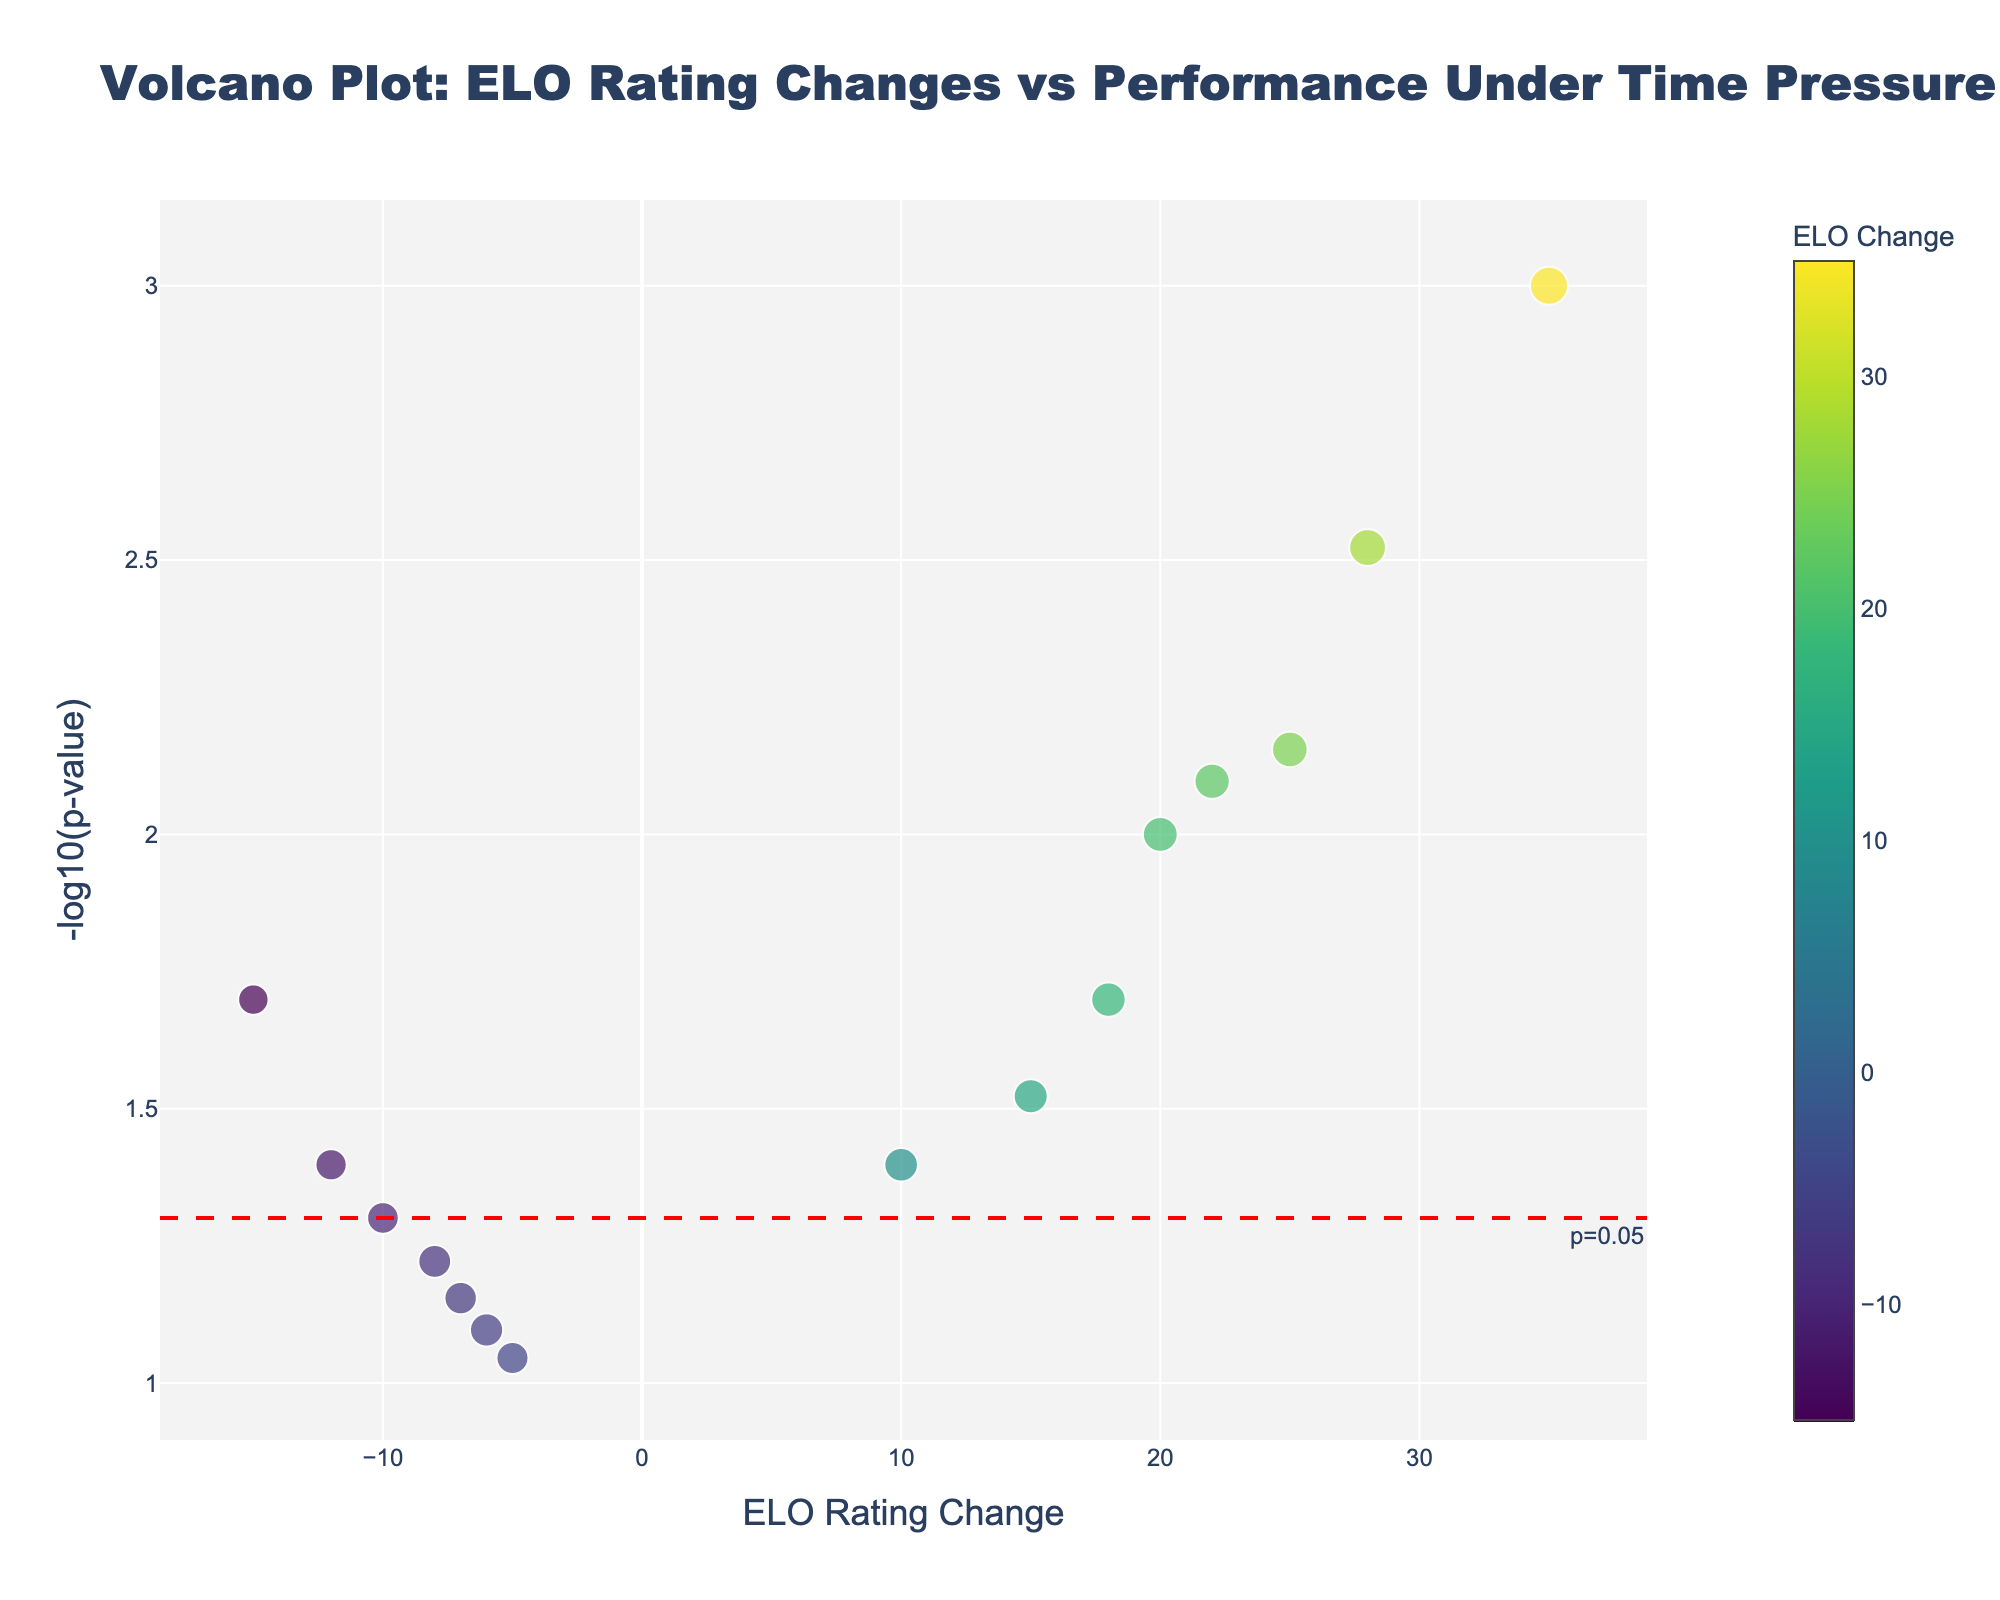What is the title of the plot? The title is located at the top of the plot in bold and larger font. It states the main purpose or message of the visualization.
Answer: "Volcano Plot: ELO Rating Changes vs Performance Under Time Pressure" What does the x-axis represent? The x-axis is labeled at the bottom showing the metric measured horizontally. It indicates the change in ELO ratings of the chess players.
Answer: ELO Rating Change What does the y-axis represent? The y-axis is labeled vertically on the left or right showing the metric measured vertically. It indicates the significance of the correlation through -log10(p-value).
Answer: -log10(p-value) How many players have a positive ELO change? Count the number of data points (players) to the right of the y-axis (where x > 0).
Answer: 7 Which player has the most significant correlation in the plot? Find the player with the highest -log10(p-value), represented by the highest point on the plot.
Answer: Magnus Carlsen What is the -log10(p-value) for Ding Liren? Locate Ding Liren's data point and read the corresponding value on the y-axis.
Answer: 1.398 How do Magnus Carlsen and Hikaru Nakamura compare in terms of time pressure performance? Compare the time pressure performance values (represented by marker size) for both players.
Answer: Carlsen: 0.95, Nakamura: 0.92 Which player has the smallest positive ELO change? Identify the player with the smallest positive value on the x-axis.
Answer: Alexander Grischuk What is the relationship between ELO change and time pressure performance among all players? Observe the trend or pattern by looking at the sizes and positions of the markers on the plot. Larger marker sizes tend to correlate with positive ELO changes.
Answer: Generally, better time pressure performance correlates with positive ELO changes 